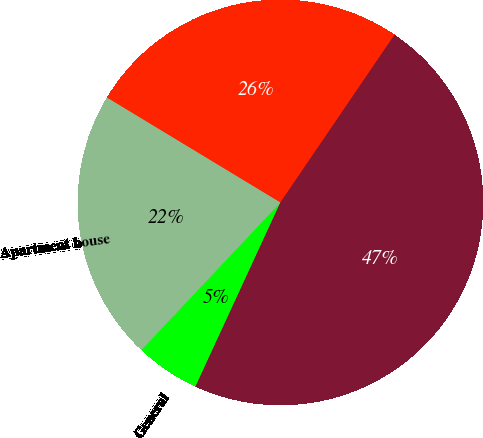Convert chart. <chart><loc_0><loc_0><loc_500><loc_500><pie_chart><fcel>General<fcel>Apartment house<fcel>Annual power<fcel>Total<nl><fcel>5.15%<fcel>21.63%<fcel>25.85%<fcel>47.37%<nl></chart> 